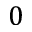Convert formula to latex. <formula><loc_0><loc_0><loc_500><loc_500>0</formula> 